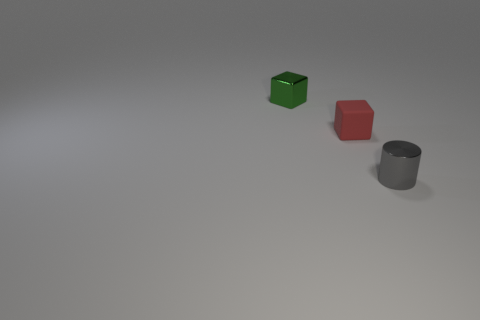What size is the block to the right of the tiny shiny thing on the left side of the thing right of the tiny red cube?
Offer a terse response. Small. What color is the small thing that is both in front of the tiny green thing and behind the cylinder?
Provide a short and direct response. Red. There is a matte block; is its size the same as the metal thing right of the shiny cube?
Your answer should be very brief. Yes. Are there any other things that are the same shape as the red rubber object?
Keep it short and to the point. Yes. What color is the other small thing that is the same shape as the small green metallic object?
Offer a very short reply. Red. Is the gray shiny cylinder the same size as the rubber cube?
Make the answer very short. Yes. What number of other objects are there of the same size as the red rubber cube?
Give a very brief answer. 2. What number of things are things to the right of the small matte block or metal things that are to the left of the tiny gray metal cylinder?
Provide a short and direct response. 2. What shape is the green metallic object that is the same size as the red cube?
Your answer should be compact. Cube. What is the size of the object that is the same material as the small gray cylinder?
Provide a short and direct response. Small. 